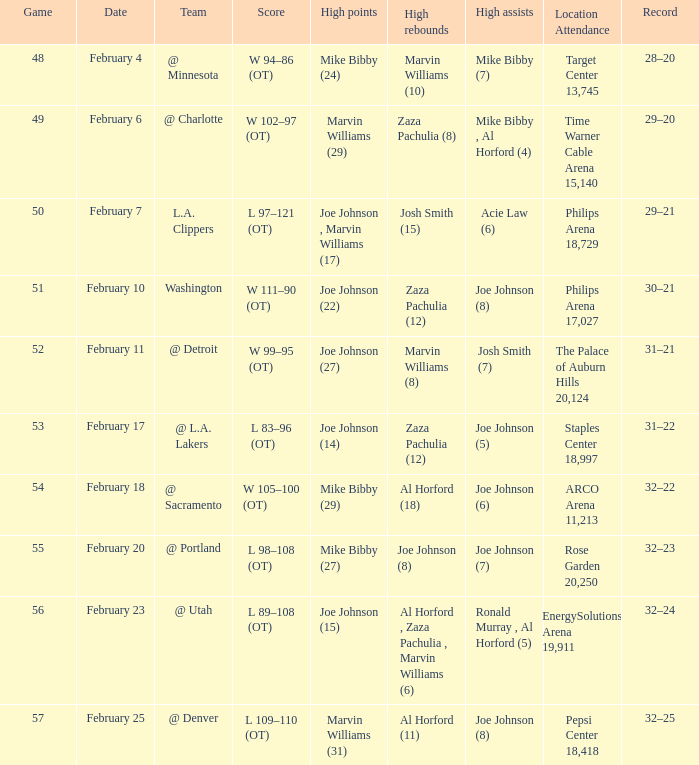How many high assists stats were maade on february 4 1.0. 